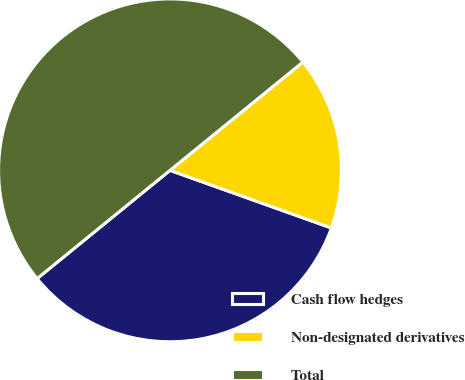<chart> <loc_0><loc_0><loc_500><loc_500><pie_chart><fcel>Cash flow hedges<fcel>Non-designated derivatives<fcel>Total<nl><fcel>33.66%<fcel>16.34%<fcel>50.0%<nl></chart> 